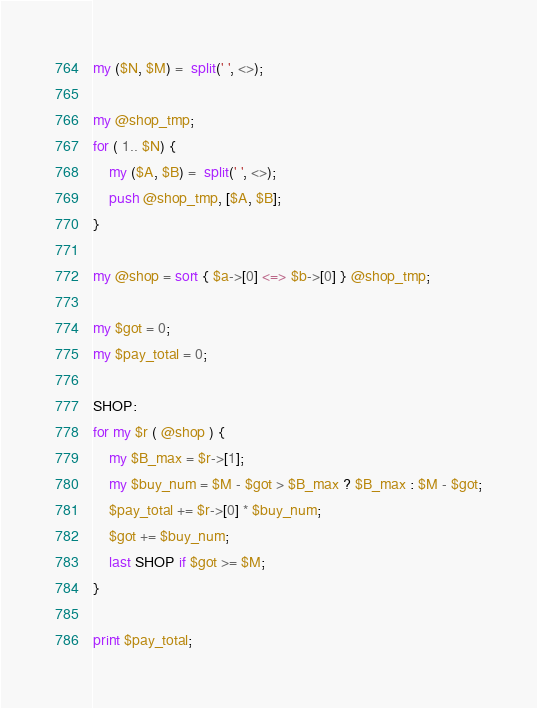<code> <loc_0><loc_0><loc_500><loc_500><_Perl_>my ($N, $M) =  split(' ', <>);

my @shop_tmp;
for ( 1.. $N) {
    my ($A, $B) =  split(' ', <>);
    push @shop_tmp, [$A, $B];
}

my @shop = sort { $a->[0] <=> $b->[0] } @shop_tmp;

my $got = 0;
my $pay_total = 0;

SHOP:
for my $r ( @shop ) {
    my $B_max = $r->[1];
    my $buy_num = $M - $got > $B_max ? $B_max : $M - $got;
    $pay_total += $r->[0] * $buy_num;
    $got += $buy_num;
    last SHOP if $got >= $M;
}

print $pay_total;</code> 